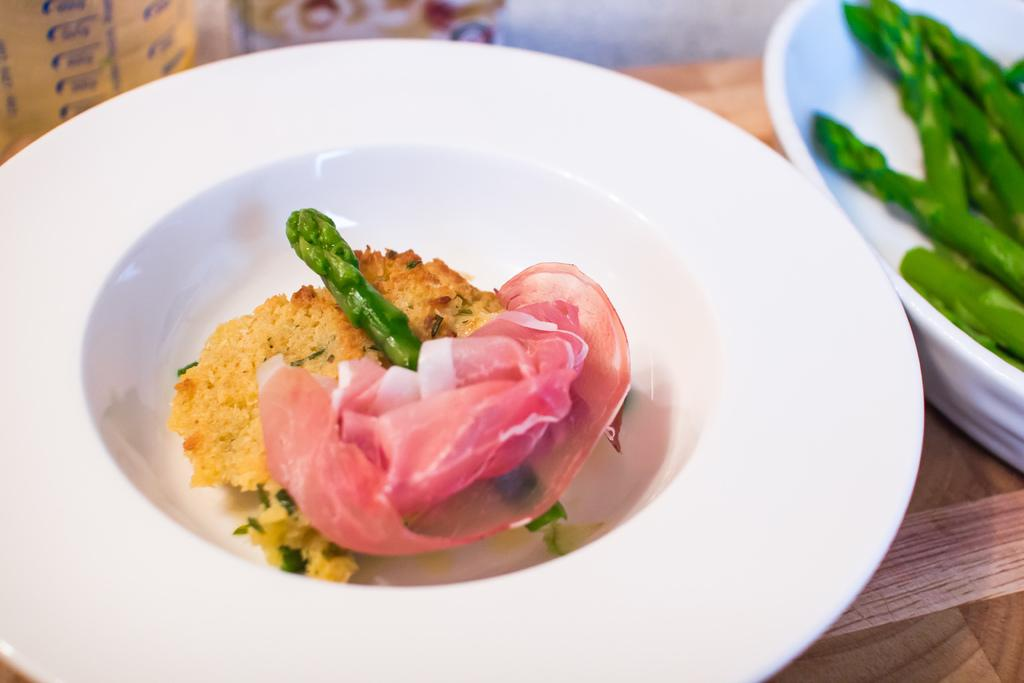What is in the bowls that are visible in the image? There are food items in bowls in the image. Where are the bowls placed? The bowls are on a wooden platform. What can be seen in the background of the image? There are objects visible in the background of the image. How many times does the office stretch in the image? There is no office present in the image, so it cannot be stretched or counted. 